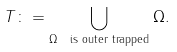Convert formula to latex. <formula><loc_0><loc_0><loc_500><loc_500>T \colon = \bigcup _ { \Omega \ \text {is outer trapped} } \Omega .</formula> 